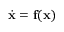Convert formula to latex. <formula><loc_0><loc_0><loc_500><loc_500>\dot { x } = f ( x )</formula> 